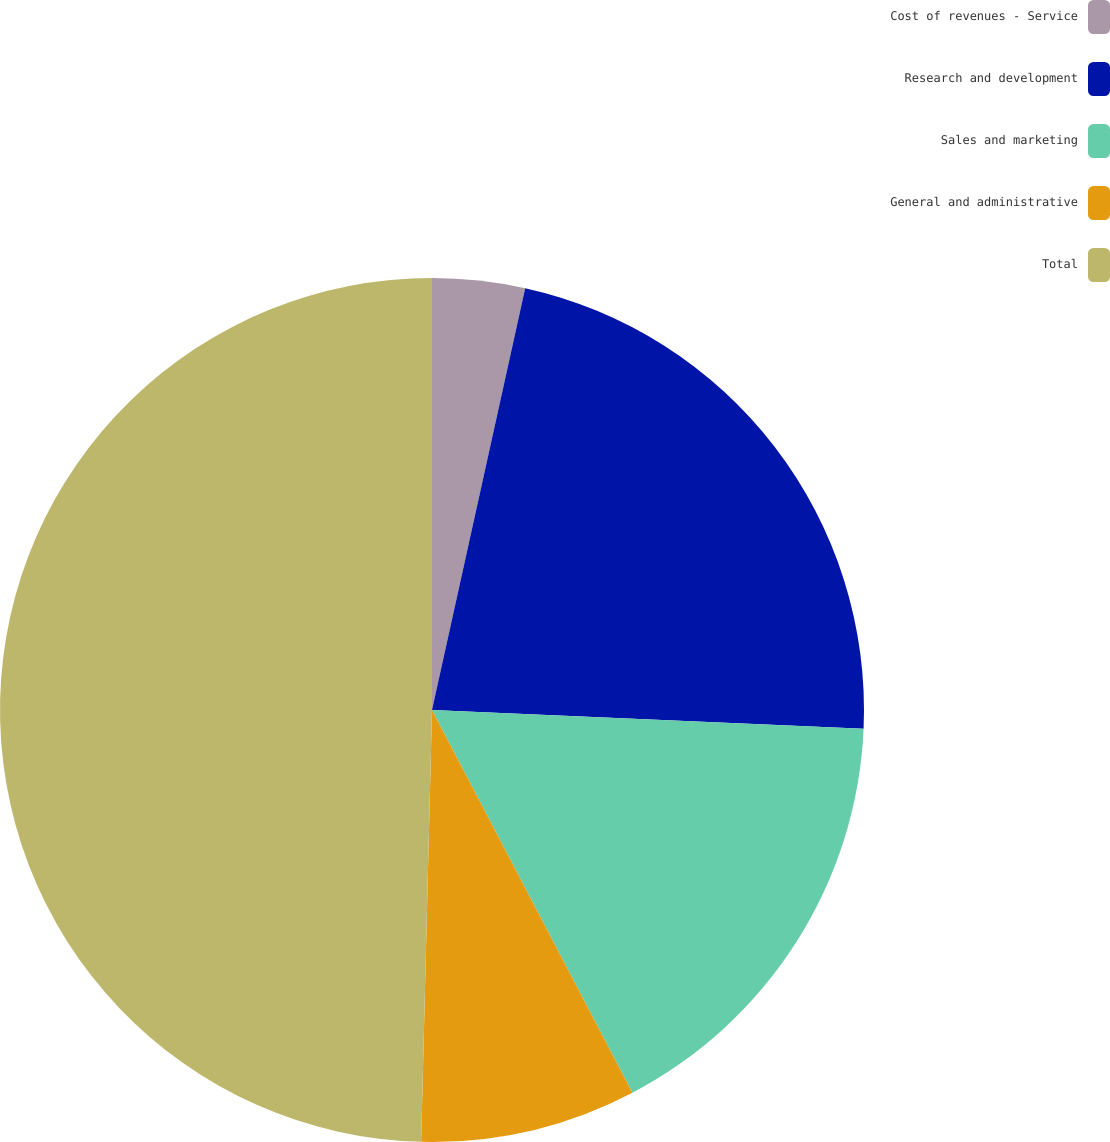Convert chart to OTSL. <chart><loc_0><loc_0><loc_500><loc_500><pie_chart><fcel>Cost of revenues - Service<fcel>Research and development<fcel>Sales and marketing<fcel>General and administrative<fcel>Total<nl><fcel>3.46%<fcel>22.23%<fcel>16.63%<fcel>8.08%<fcel>49.6%<nl></chart> 